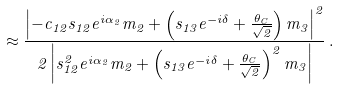Convert formula to latex. <formula><loc_0><loc_0><loc_500><loc_500>\approx \frac { \left | - c _ { 1 2 } s _ { 1 2 } e ^ { i \alpha _ { 2 } } m _ { 2 } + \left ( s _ { 1 3 } e ^ { - i \delta } + \frac { \theta _ { C } } { \sqrt { 2 } } \right ) m _ { 3 } \right | ^ { 2 } } { 2 \left | s ^ { 2 } _ { 1 2 } e ^ { i \alpha _ { 2 } } m _ { 2 } + \left ( s _ { 1 3 } e ^ { - i \delta } + \frac { \theta _ { C } } { \sqrt { 2 } } \right ) ^ { 2 } m _ { 3 } \right | } \, .</formula> 